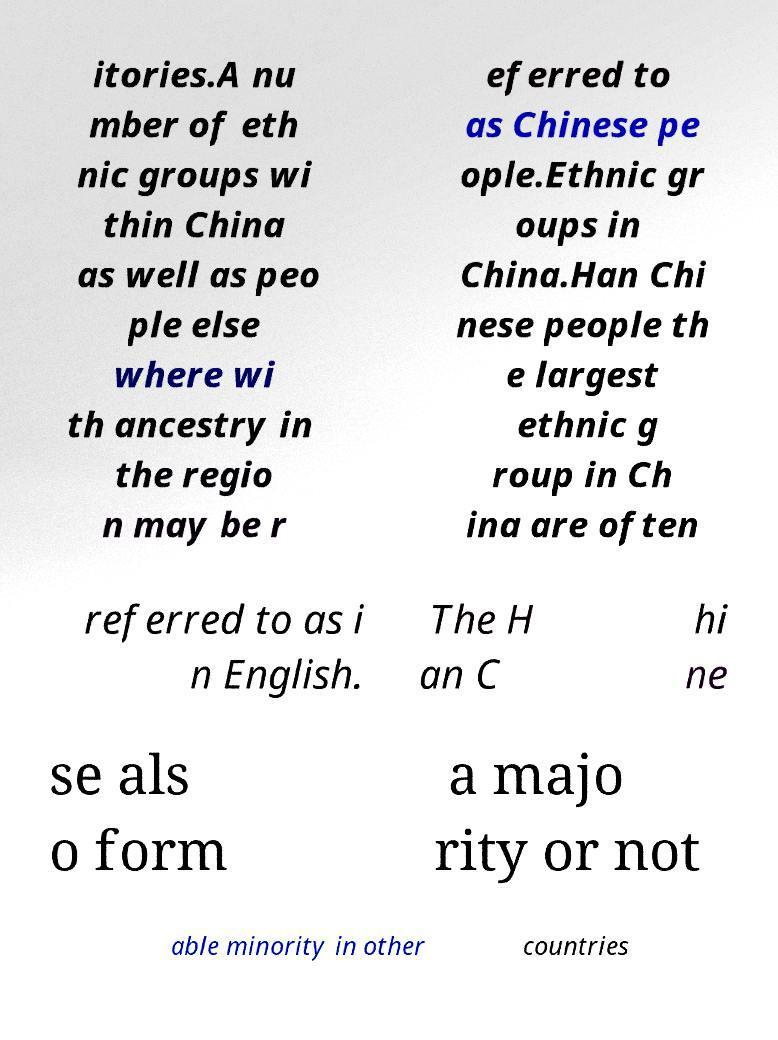What messages or text are displayed in this image? I need them in a readable, typed format. itories.A nu mber of eth nic groups wi thin China as well as peo ple else where wi th ancestry in the regio n may be r eferred to as Chinese pe ople.Ethnic gr oups in China.Han Chi nese people th e largest ethnic g roup in Ch ina are often referred to as i n English. The H an C hi ne se als o form a majo rity or not able minority in other countries 